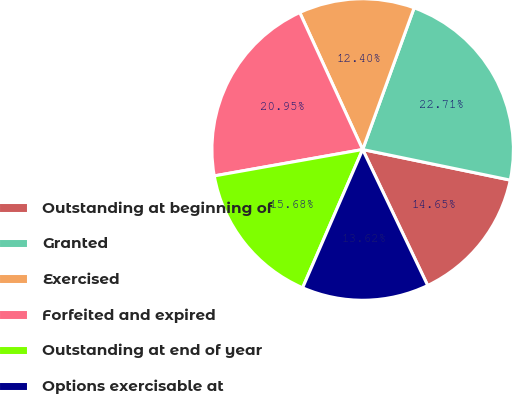<chart> <loc_0><loc_0><loc_500><loc_500><pie_chart><fcel>Outstanding at beginning of<fcel>Granted<fcel>Exercised<fcel>Forfeited and expired<fcel>Outstanding at end of year<fcel>Options exercisable at<nl><fcel>14.65%<fcel>22.71%<fcel>12.4%<fcel>20.95%<fcel>15.68%<fcel>13.62%<nl></chart> 